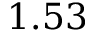Convert formula to latex. <formula><loc_0><loc_0><loc_500><loc_500>1 . 5 3</formula> 